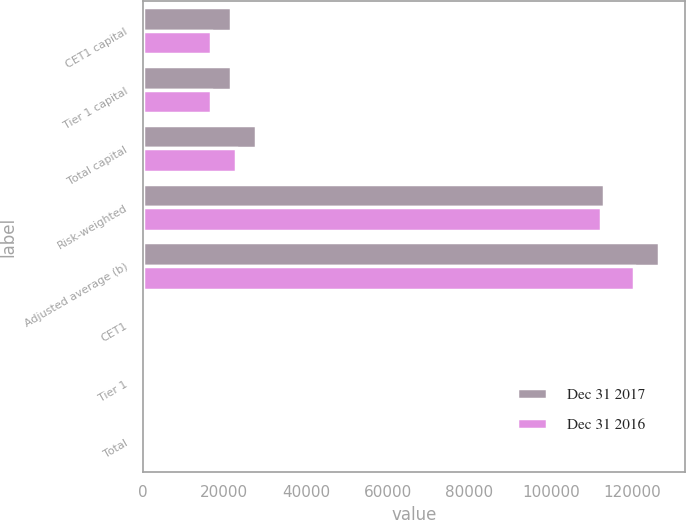Convert chart to OTSL. <chart><loc_0><loc_0><loc_500><loc_500><stacked_bar_chart><ecel><fcel>CET1 capital<fcel>Tier 1 capital<fcel>Total capital<fcel>Risk-weighted<fcel>Adjusted average (b)<fcel>CET1<fcel>Tier 1<fcel>Total<nl><fcel>Dec 31 2017<fcel>21600<fcel>21600<fcel>27691<fcel>113108<fcel>126517<fcel>19.1<fcel>19.1<fcel>24.5<nl><fcel>Dec 31 2016<fcel>16784<fcel>16784<fcel>22862<fcel>112297<fcel>120304<fcel>14.9<fcel>14.9<fcel>20.4<nl></chart> 